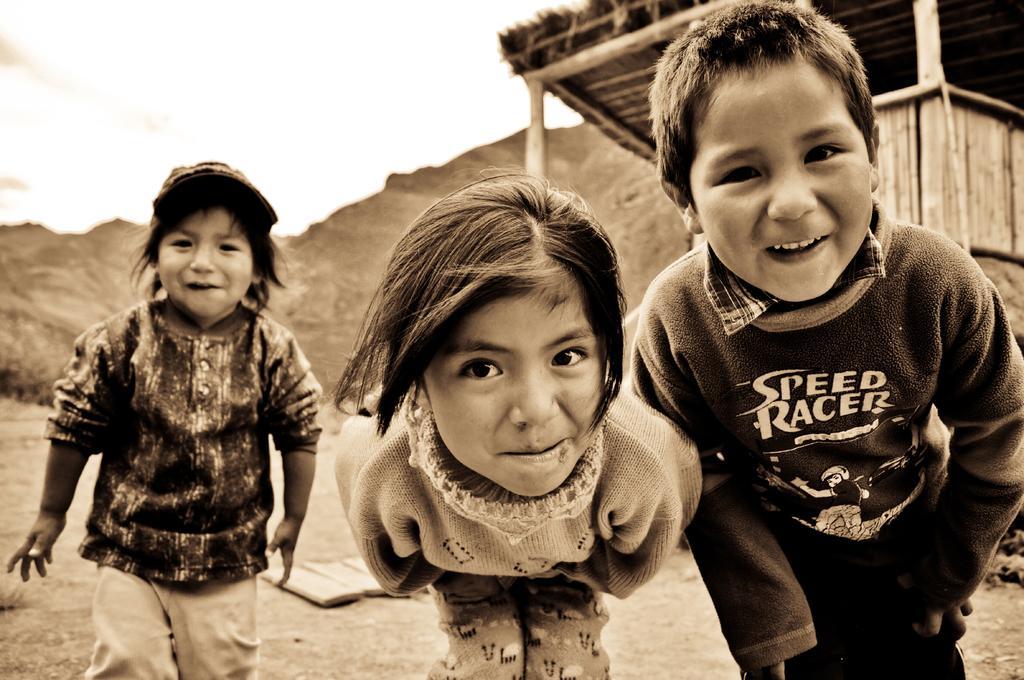How would you summarize this image in a sentence or two? In this image I can see 3 children in the front. There is a shack and mountains at the back. There is sky at the top. 